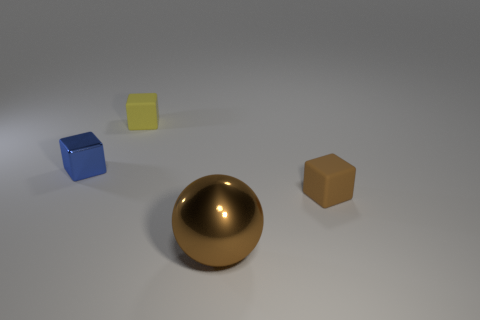Subtract all blue metallic blocks. How many blocks are left? 2 Add 1 big metallic balls. How many objects exist? 5 Subtract all spheres. How many objects are left? 3 Add 2 tiny brown objects. How many tiny brown objects exist? 3 Subtract 1 yellow cubes. How many objects are left? 3 Subtract all gray cubes. Subtract all brown spheres. How many cubes are left? 3 Subtract all brown blocks. Subtract all small yellow matte objects. How many objects are left? 2 Add 3 tiny metal cubes. How many tiny metal cubes are left? 4 